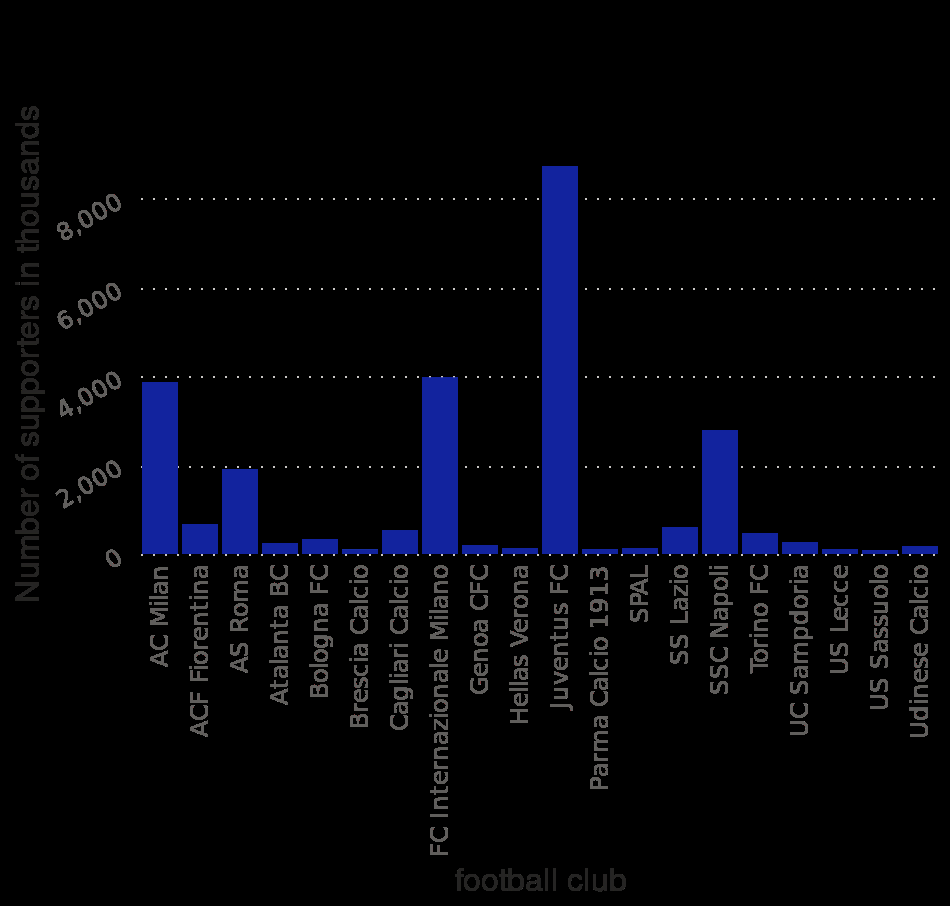<image>
Describe the following image in detail Here a is a bar chart labeled Number of Serie A football club supporters in Italy in the season 2019/2020 , by club (in 1,000s). The y-axis measures Number of supporters in thousands while the x-axis measures football club. What is the title of the bar chart?  The title of the bar chart is "Number of Serie A football club supporters in Italy in the season 2019/2020, by club (in 1,000s)." please summary the statistics and relations of the chart Juventus FC appears to almost have more supporters than the rest of the football clubs combined.  While hard to exactly see, it appears that US Sassuolo has the least amount of supporters of all of the football clubs. Football clubs seem to have a lot of supporters for the top teams and not very man supporters for the rest. Which football club seems to have the largest number of supporters?  Juventus FC appears to almost have more supporters than the rest of the football clubs combined. 